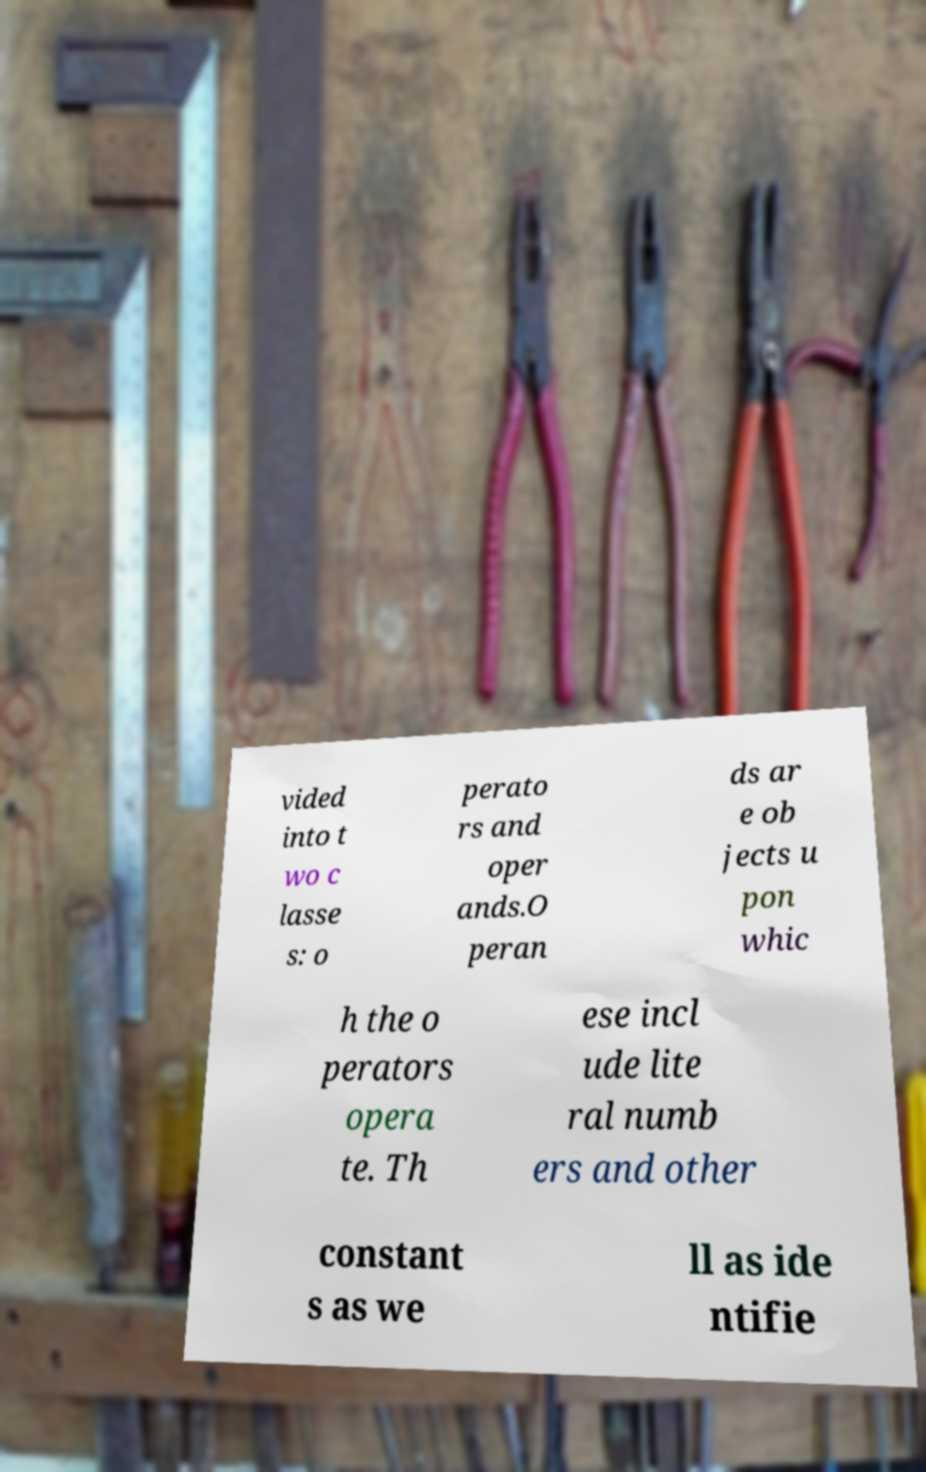For documentation purposes, I need the text within this image transcribed. Could you provide that? vided into t wo c lasse s: o perato rs and oper ands.O peran ds ar e ob jects u pon whic h the o perators opera te. Th ese incl ude lite ral numb ers and other constant s as we ll as ide ntifie 